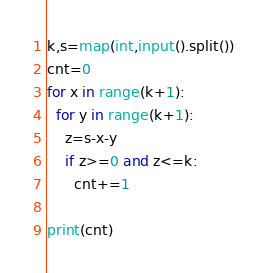<code> <loc_0><loc_0><loc_500><loc_500><_Python_>k,s=map(int,input().split())
cnt=0
for x in range(k+1):
  for y in range(k+1):
    z=s-x-y
    if z>=0 and z<=k:
      cnt+=1
        
print(cnt)</code> 